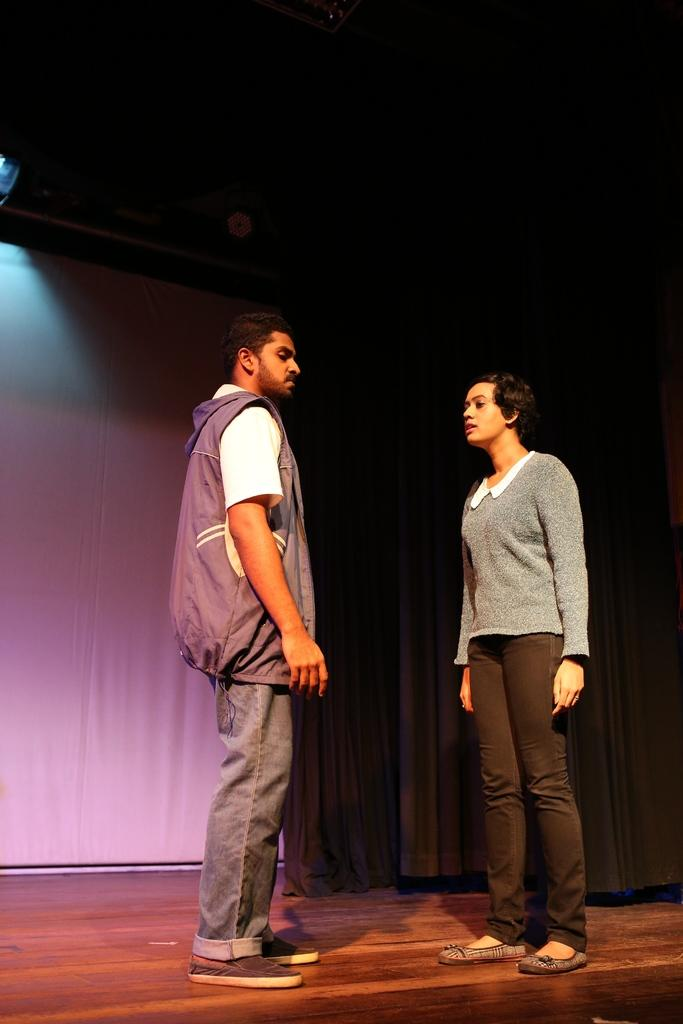How many people are in the image? There are two people in the image. Can you describe the clothing of one of the people? One of the people is wearing a jacket. What type of animals can be seen at the zoo in the image? There is no zoo or animals present in the image; it features two people. 